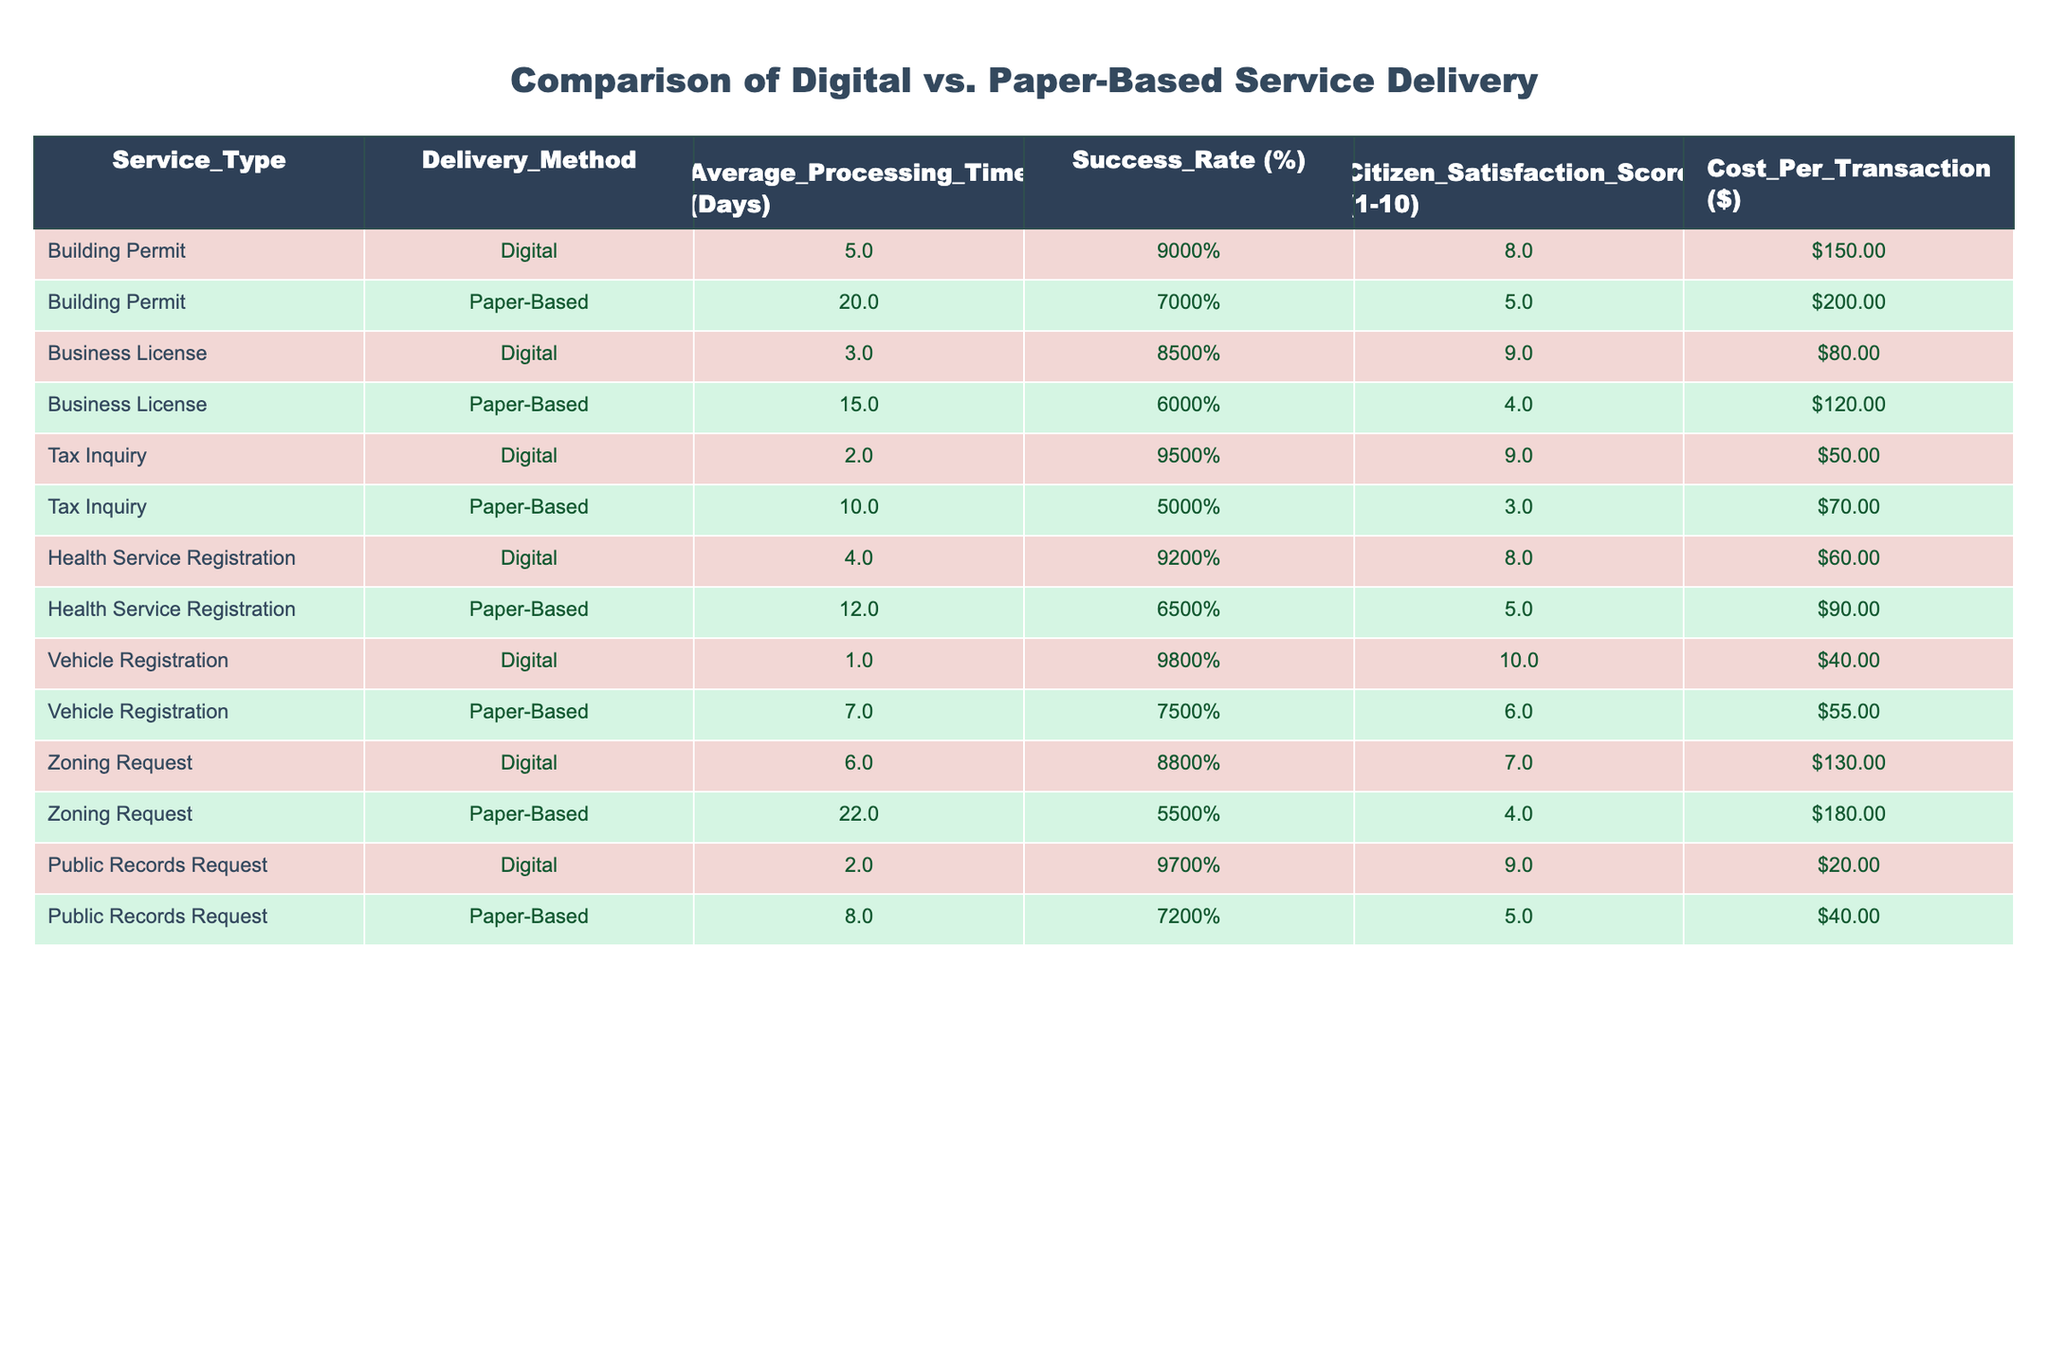What is the average processing time for digital service delivery? To find the average processing time for digital service delivery, sum the average processing times for each digital service (5 + 3 + 2 + 4 + 1 + 6 + 2) = 23 days. There are 7 services, so the average is 23/7 = 3.29 days.
Answer: 3.29 days Which delivery method has a higher success rate? Compare the overall success rates by looking at the success rate for digital services (90%, 85%, 95%, 92%, 98%, 88%, 97%) and for paper-based services (70%, 60%, 50%, 65%, 75%, 55%, 72%). The average for digital is (90 + 85 + 95 + 92 + 98 + 88 + 97) / 7 = 91.43% and for paper-based is (70 + 60 + 50 + 65 + 75 + 55 + 72) / 7 = 63.57%.
Answer: Digital What is the cost difference between the most expensive paper-based and the cheapest digital service? Identify the most expensive paper-based service, which is the zoning request at $180, and the cheapest digital service, which is the vehicle registration at $40. The cost difference is $180 - $40 = $140.
Answer: $140 Is the citizen satisfaction score for digital business licenses higher than that of paper-based business licenses? The digital business license has a satisfaction score of 9, while the paper-based business license has a score of 4. Since 9 is greater than 4, the digital service has a higher satisfaction score.
Answer: Yes How much longer does it take on average to process paper-based vehicle registration compared to digital vehicle registration? The average processing time for paper-based vehicle registration is 7 days and for digital vehicle registration is 1 day. The difference is 7 - 1 = 6 days. Therefore, it takes 6 days longer to process the paper-based vehicle registration.
Answer: 6 days What percentage of services has a delivery method that results in a citizen satisfaction score of 8 or higher? In total, there are 14 services (7 digital and 7 paper-based). The digital services with satisfaction scores of 8 or higher are Building Permit (8), Business License (9), Tax Inquiry (9), Health Service Registration (8), Vehicle Registration (10), and Public Records Request (9), totaling 6 services. Thus, the percentage is (6/14) * 100 = 42.86%.
Answer: 42.86% Which service type has the highest citizen satisfaction score and what is that score? Review the citizen satisfaction scores for all service types: Building Permit (8), Business License (9), Tax Inquiry (9), Health Service Registration (8), Vehicle Registration (10), Zoning Request (7), and Public Records Request (9). The highest score is 10 for Vehicle Registration.
Answer: 10 What is the average success rate for paper-based services? The paper-based services' success rates are 70%, 60%, 50%, 65%, 75%, 55%, and 72%. Add these success rates (70 + 60 + 50 + 65 + 75 + 55 + 72) = 447, and divide by 7 to get the average, which is 447 / 7 = 63.57%.
Answer: 63.57% 